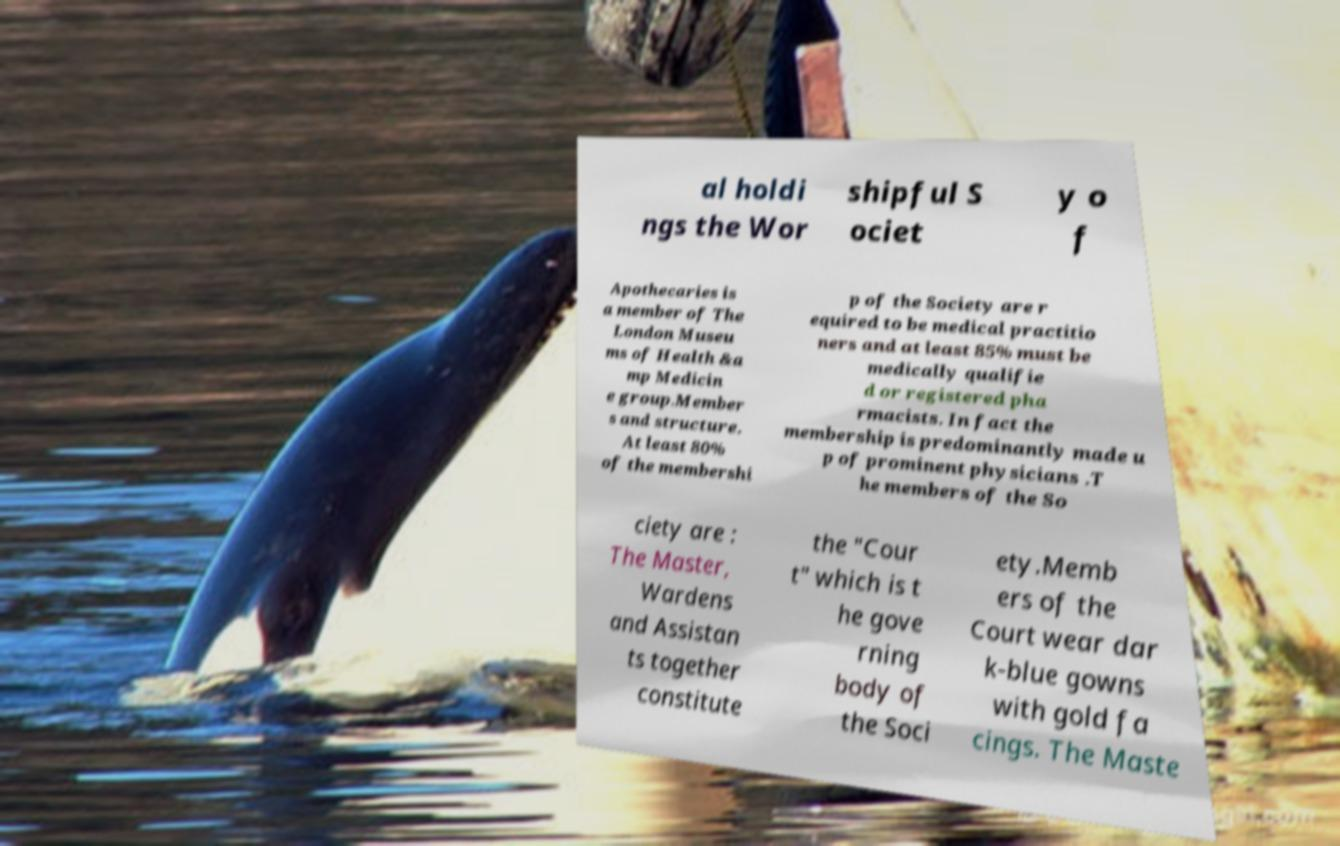Could you assist in decoding the text presented in this image and type it out clearly? al holdi ngs the Wor shipful S ociet y o f Apothecaries is a member of The London Museu ms of Health &a mp Medicin e group.Member s and structure. At least 80% of the membershi p of the Society are r equired to be medical practitio ners and at least 85% must be medically qualifie d or registered pha rmacists. In fact the membership is predominantly made u p of prominent physicians .T he members of the So ciety are : The Master, Wardens and Assistan ts together constitute the "Cour t" which is t he gove rning body of the Soci ety.Memb ers of the Court wear dar k-blue gowns with gold fa cings. The Maste 